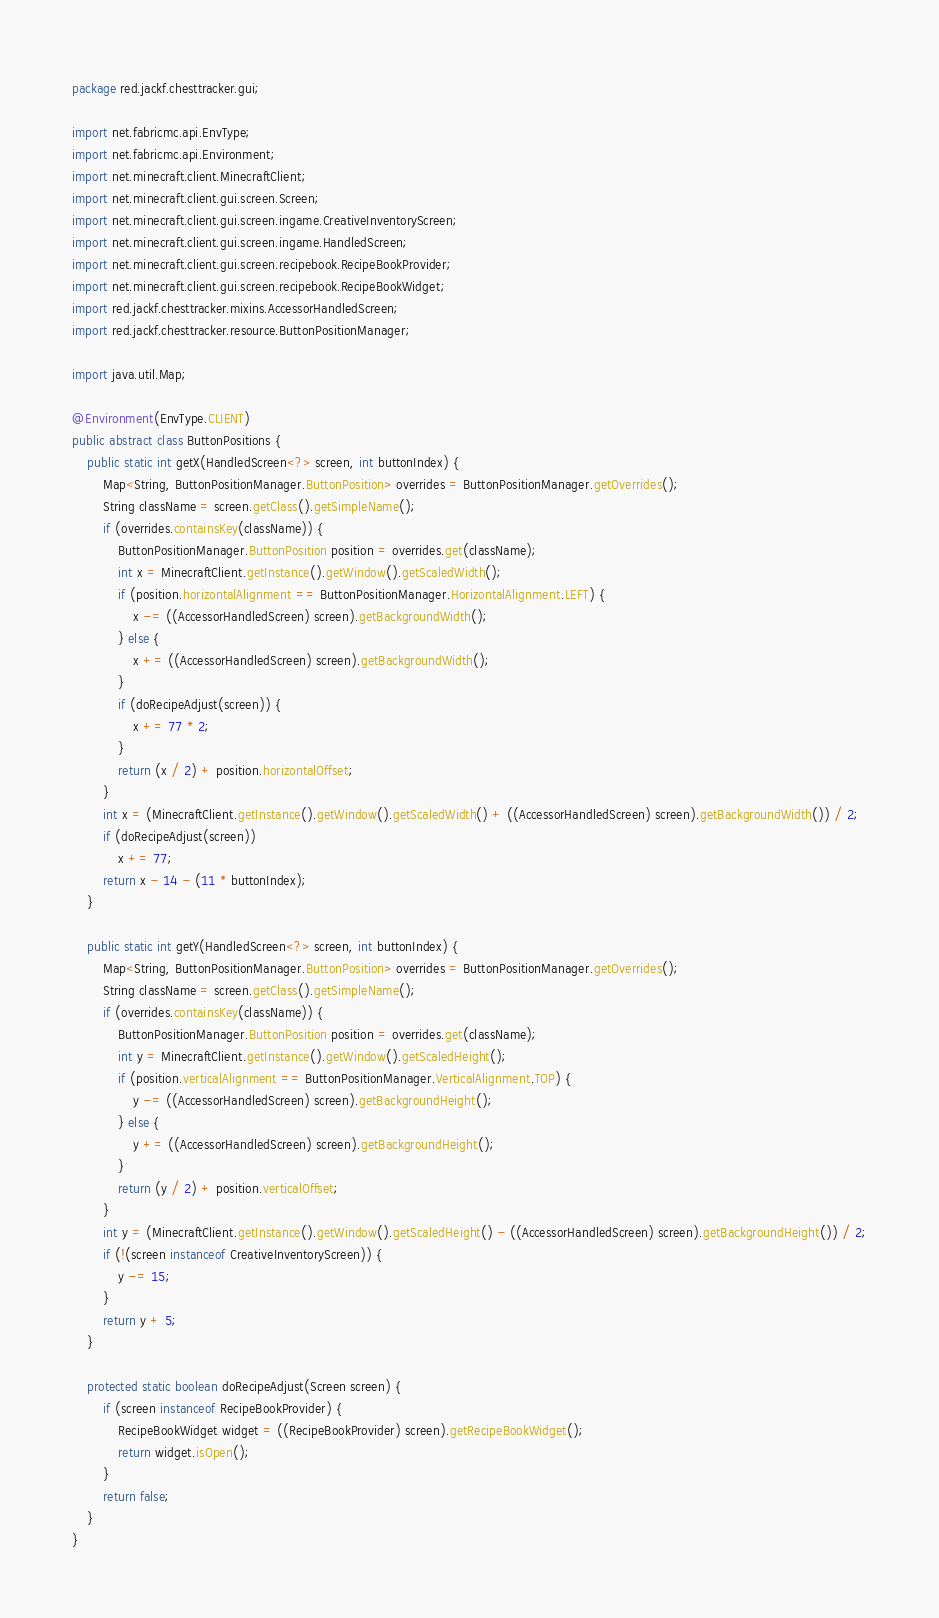<code> <loc_0><loc_0><loc_500><loc_500><_Java_>package red.jackf.chesttracker.gui;

import net.fabricmc.api.EnvType;
import net.fabricmc.api.Environment;
import net.minecraft.client.MinecraftClient;
import net.minecraft.client.gui.screen.Screen;
import net.minecraft.client.gui.screen.ingame.CreativeInventoryScreen;
import net.minecraft.client.gui.screen.ingame.HandledScreen;
import net.minecraft.client.gui.screen.recipebook.RecipeBookProvider;
import net.minecraft.client.gui.screen.recipebook.RecipeBookWidget;
import red.jackf.chesttracker.mixins.AccessorHandledScreen;
import red.jackf.chesttracker.resource.ButtonPositionManager;

import java.util.Map;

@Environment(EnvType.CLIENT)
public abstract class ButtonPositions {
    public static int getX(HandledScreen<?> screen, int buttonIndex) {
        Map<String, ButtonPositionManager.ButtonPosition> overrides = ButtonPositionManager.getOverrides();
        String className = screen.getClass().getSimpleName();
        if (overrides.containsKey(className)) {
            ButtonPositionManager.ButtonPosition position = overrides.get(className);
            int x = MinecraftClient.getInstance().getWindow().getScaledWidth();
            if (position.horizontalAlignment == ButtonPositionManager.HorizontalAlignment.LEFT) {
                x -= ((AccessorHandledScreen) screen).getBackgroundWidth();
            } else {
                x += ((AccessorHandledScreen) screen).getBackgroundWidth();
            }
            if (doRecipeAdjust(screen)) {
                x += 77 * 2;
            }
            return (x / 2) + position.horizontalOffset;
        }
        int x = (MinecraftClient.getInstance().getWindow().getScaledWidth() + ((AccessorHandledScreen) screen).getBackgroundWidth()) / 2;
        if (doRecipeAdjust(screen))
            x += 77;
        return x - 14 - (11 * buttonIndex);
    }

    public static int getY(HandledScreen<?> screen, int buttonIndex) {
        Map<String, ButtonPositionManager.ButtonPosition> overrides = ButtonPositionManager.getOverrides();
        String className = screen.getClass().getSimpleName();
        if (overrides.containsKey(className)) {
            ButtonPositionManager.ButtonPosition position = overrides.get(className);
            int y = MinecraftClient.getInstance().getWindow().getScaledHeight();
            if (position.verticalAlignment == ButtonPositionManager.VerticalAlignment.TOP) {
                y -= ((AccessorHandledScreen) screen).getBackgroundHeight();
            } else {
                y += ((AccessorHandledScreen) screen).getBackgroundHeight();
            }
            return (y / 2) + position.verticalOffset;
        }
        int y = (MinecraftClient.getInstance().getWindow().getScaledHeight() - ((AccessorHandledScreen) screen).getBackgroundHeight()) / 2;
        if (!(screen instanceof CreativeInventoryScreen)) {
            y -= 15;
        }
        return y + 5;
    }

    protected static boolean doRecipeAdjust(Screen screen) {
        if (screen instanceof RecipeBookProvider) {
            RecipeBookWidget widget = ((RecipeBookProvider) screen).getRecipeBookWidget();
            return widget.isOpen();
        }
        return false;
    }
}
</code> 